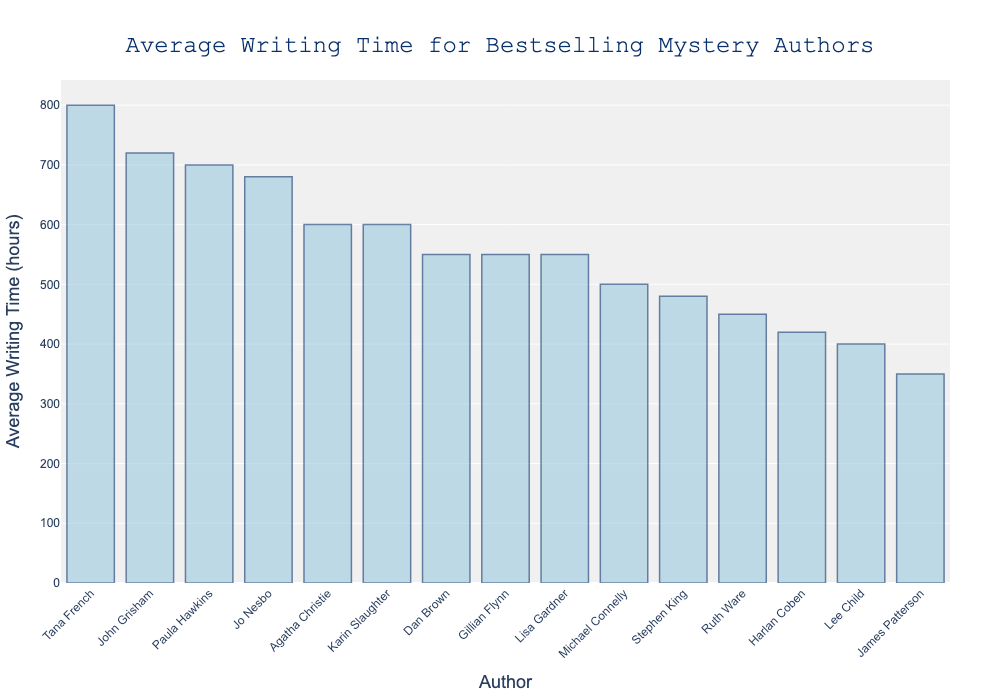Who has the highest average writing time? Tana French has the highest bar in the chart, indicating the longest average writing time.
Answer: Tana French Who has the shortest average writing time? James Patterson has the shortest bar in the chart, indicating the shortest average writing time.
Answer: James Patterson What is the average writing time for Agatha Christie and Stephen King combined? Agatha Christie's writing time is 600 hours, and Stephen King's writing time is 480 hours. Combined, it is (600 + 480) = 1080 hours.
Answer: 1080 hours How much longer does Tana French take to write a book compared to Lee Child? Tana French's writing time is 800 hours and Lee Child's writing time is 400 hours. The difference is (800 - 400) = 400 hours.
Answer: 400 hours Who are the second and third fastest writers? The second shortest writing time is for Stephen King with 480 hours, and the third shortest is for Ruth Ware with 450 hours.
Answer: Stephen King and Ruth Ware What is the sum of the average writing times for Dan Brown, Gillian Flynn, and Paula Hawkins? Dan Brown's writing time is 550 hours, Gillian Flynn's is 550 hours, and Paula Hawkins' is 700 hours. The sum is (550 + 550 + 700) = 1800 hours.
Answer: 1800 hours Is John Grisham's average writing time greater than Jo Nesbo's? John Grisham's writing time is 720 hours, while Jo Nesbo's is 680 hours. Comparing the two, 720 > 680.
Answer: Yes Which authors have an average writing time of exactly 600 hours? Agatha Christie and Karin Slaughter both have bars indicating an average writing time of 600 hours.
Answer: Agatha Christie and Karin Slaughter What is the range of the average writing times for all authors? The highest writing time is for Tana French at 800 hours, and the lowest is for James Patterson at 350 hours. The range is (800 - 350) = 450 hours.
Answer: 450 hours How much more time on average does Paula Hawkins take compared to Michael Connelly? Paula Hawkins' writing time is 700 hours, and Michael Connelly's is 500 hours. The difference is (700 - 500) = 200 hours.
Answer: 200 hours 